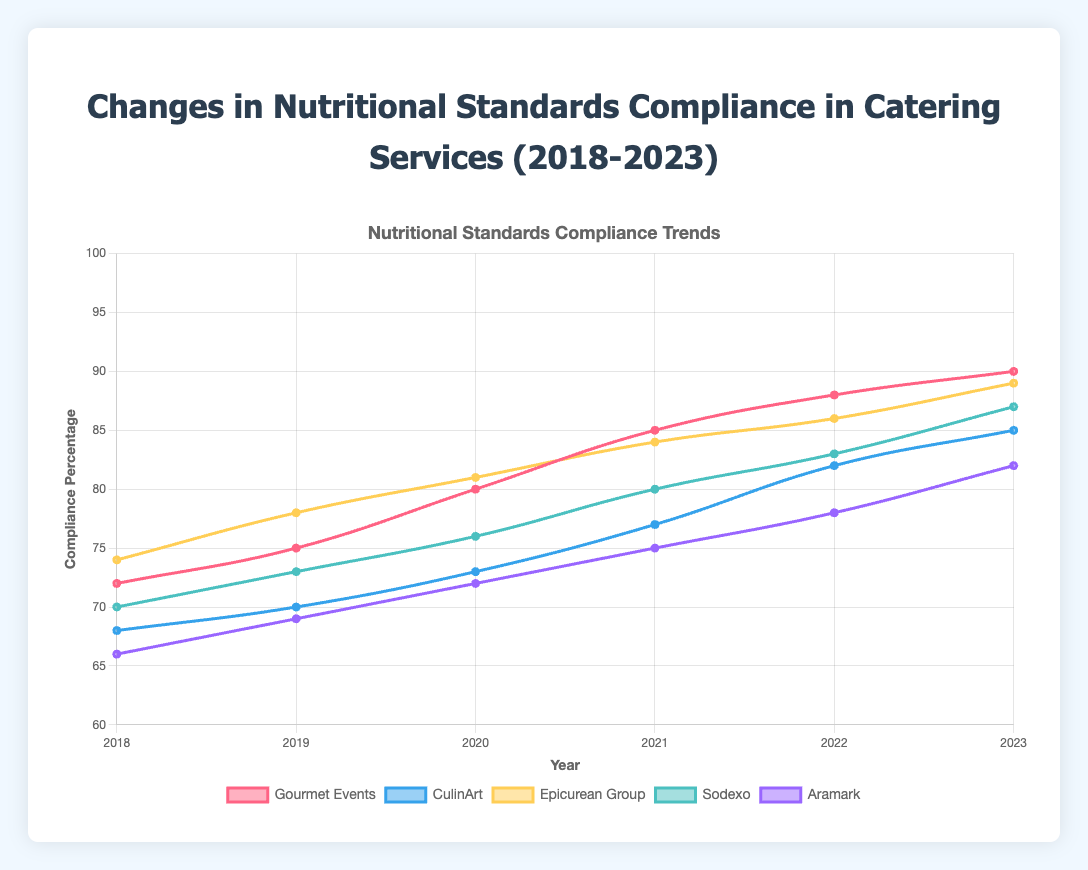What is the average compliance percentage for Gourmet Events from 2018 to 2023? Sum all compliance percentages for Gourmet Events (72 + 75 + 80 + 85 + 88 + 90 = 490) and divide by the number of years (6). The average compliance percentage is 490/6 = 81.67
Answer: 81.67 Which provider showed the highest compliance percentage in 2023? In the year 2023, compare the compliance percentages of all providers: Gourmet Events (90), CulinArt (85), Epicurean Group (89), Sodexo (87), and Aramark (82). The highest percentage is for Gourmet Events with 90%
Answer: Gourmet Events How much did CulinArt's compliance percentage increase from 2018 to 2023? Subtract CulinArt's 2018 compliance percentage (68) from its 2023 compliance percentage (85). The increase is 85 - 68 = 17
Answer: 17 Which provider had the lowest compliance percentage in 2018? Compare the 2018 compliance percentages of all providers: Gourmet Events (72), CulinArt (68), Epicurean Group (74), Sodexo (70), and Aramark (66). Aramark has the lowest percentage at 66%
Answer: Aramark Between which two years did Epicurean Group see the largest increase in compliance percentage? Calculate the year-over-year increases for Epicurean Group: 2018-2019 (78 - 74 = 4), 2019-2020 (81 - 78 = 3), 2020-2021 (84 - 81 = 3), 2021-2022 (86 - 84 = 2), and 2022-2023 (89 - 86 = 3). The largest increase is between 2018 and 2019, with an increase of 4%
Answer: 2018-2019 Which provider showed the smallest range of compliance percentages over the years 2018 to 2023? Calculate the range (difference between the highest and lowest compliance percentages) for each provider: Gourmet Events (90 - 72 = 18), CulinArt (85 - 68 = 17), Epicurean Group (89 - 74 = 15), Sodexo (87 - 70 = 17), and Aramark (82 - 66 = 16). The smallest range is for Epicurean Group with 15%
Answer: Epicurean Group What was the average compliance percentage across all providers in 2021? Sum the 2021 compliance percentages for all providers (85 + 77 + 84 + 80 + 75 = 401) and divide by the number of providers (5). The average compliance percentage is 401/5 = 80.2
Answer: 80.2 Which provider had the most consistent year-over-year improvement in compliance percentages from 2018 to 2023? Examine year-over-year improvements: Gourmet Events (3, 5, 5, 3, 2), CulinArt (2, 3, 4, 5, 3), Epicurean Group (4, 3, 3, 2, 3), Sodexo (3, 3, 4, 3, 4), Aramark (3, 3, 3, 3, 4). The most consistent and steady year-over-year improvement (mostly constant increases) appears to be for Gourmet Events
Answer: Gourmet Events By how much did the compliance percentage of Sodexo improve from 2020 to 2023? Subtract Sodexo's 2020 compliance percentage (76) from its 2023 compliance percentage (87). The improvement is 87 - 76 = 11
Answer: 11 Which provider had the highest average compliance percentage over the 6 years? Calculate the average compliance for each provider: 
- Gourmet Events: (72 + 75 + 80 + 85 + 88 + 90)/6 = 81.67
- CulinArt: (68 + 70 + 73 + 77 + 82 + 85)/6 = 75.83
- Epicurean Group: (74 + 78 + 81 + 84 + 86 + 89)/6 = 82
- Sodexo: (70 + 73 + 76 + 80 + 83 + 87)/6 = 78.17
- Aramark: (66 + 69 + 72 + 75 + 78 + 82)/6 = 73.67
The highest average compliance is 82% for Epicurean Group
Answer: Epicurean Group 